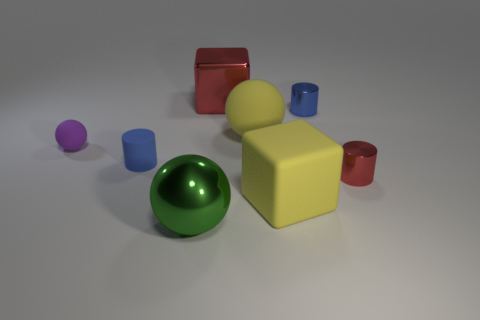How many other objects are the same color as the big metal cube?
Keep it short and to the point. 1. There is a large thing on the right side of the big yellow object behind the small blue rubber cylinder; what is it made of?
Ensure brevity in your answer.  Rubber. Are there any large objects?
Make the answer very short. Yes. There is a blue object that is to the left of the large block that is left of the yellow cube; what size is it?
Give a very brief answer. Small. Are there more metal cylinders behind the red cylinder than green balls that are in front of the green sphere?
Your answer should be compact. Yes. What number of blocks are small matte things or large green things?
Your answer should be compact. 0. Is there anything else that has the same size as the yellow ball?
Offer a terse response. Yes. There is a rubber object that is on the left side of the blue rubber cylinder; does it have the same shape as the tiny blue rubber object?
Provide a short and direct response. No. The big matte block is what color?
Offer a terse response. Yellow. There is another small matte object that is the same shape as the green object; what is its color?
Provide a short and direct response. Purple. 